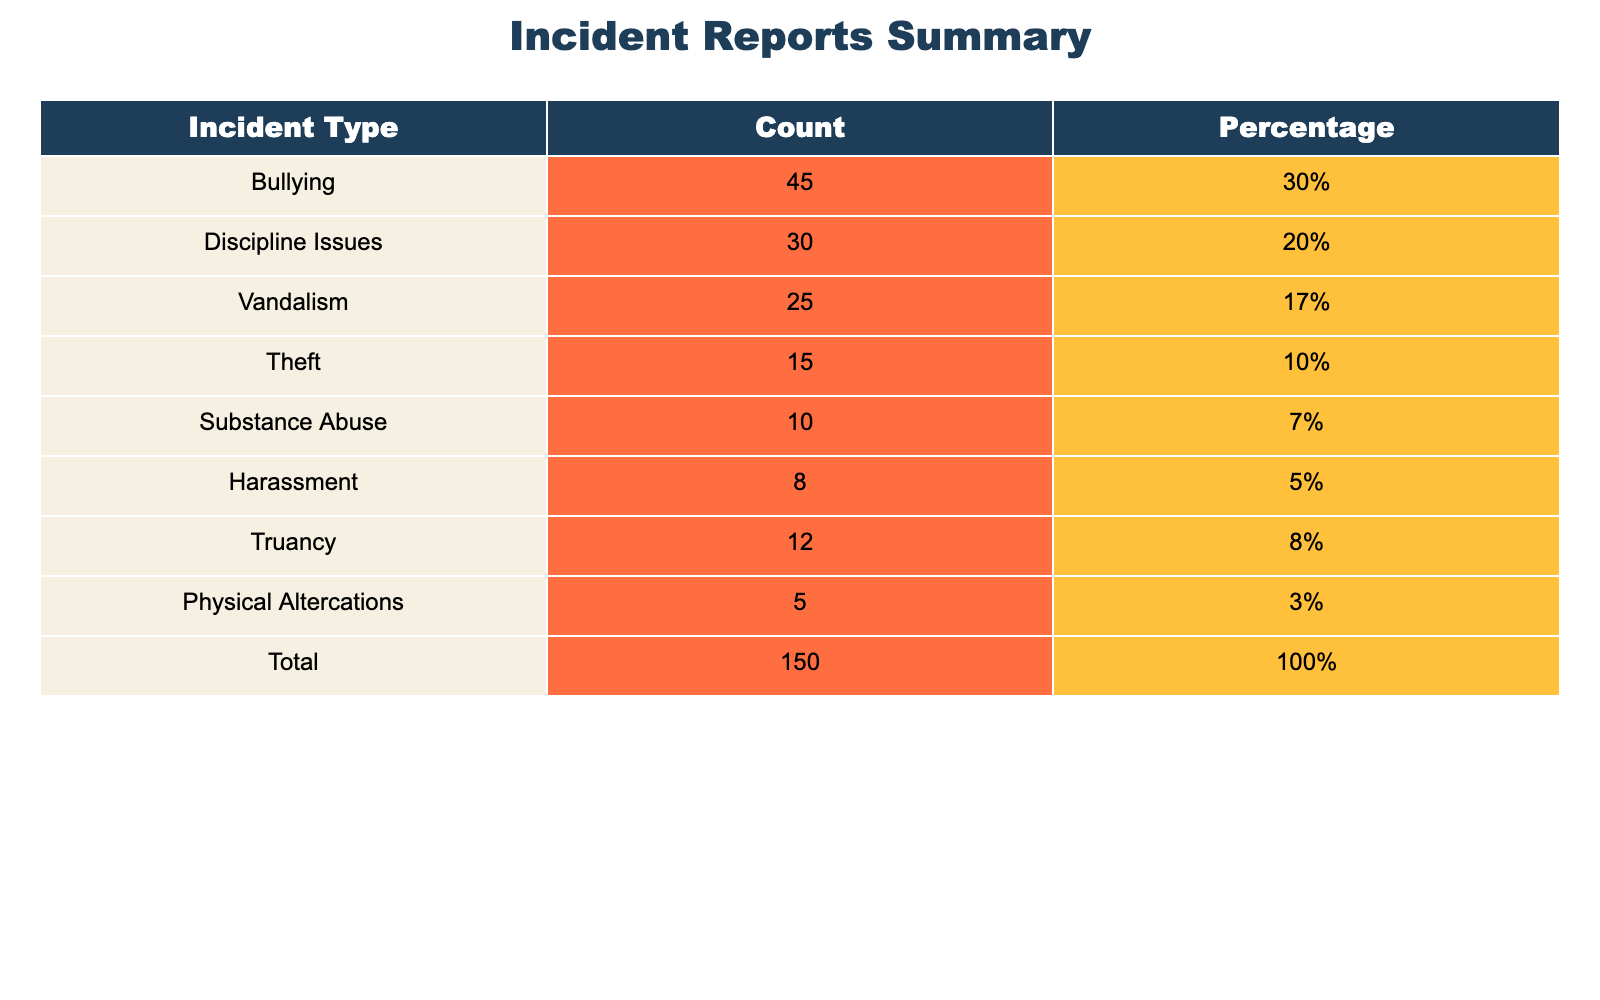What is the total number of incident reports? The total number of incident reports is given in the last row of the table under the "Total" column, which states 150.
Answer: 150 What percentage of incidents are related to bullying? The percentage related to bullying is found directly in the table under the "Percentage" column for "Bullying," which is 30%.
Answer: 30% How many incidents were reported for theft? The count of incidents for theft can be directly found in the "Count" column next to "Theft," which is 15.
Answer: 15 What is the combined number of incidents for substance abuse and harassment? To find the combined number, we add the counts for substance abuse (10) and harassment (8) together: 10 + 8 = 18.
Answer: 18 Is it true that bullying incidents account for more than a fifth of the total incidents? We check if bullying incidents, which are 45, represent more than 20% of the total incidents (150). Calculating 20% of 150 gives 30, and since 45 is greater than 30, the statement is true.
Answer: Yes How does the number of vandalism incidents compare to truancy incidents? Vandalism has 25 incidents, and truancy has 12. Since 25 is greater than 12, vandalism incidents are higher than truancy incidents.
Answer: Vandalism incidents are higher What percentage of the total incidents are characterized by discipline issues and physical altercations combined? First, we find the counts for discipline issues (30) and physical altercations (5) and add them: 30 + 5 = 35. To find the percentage, we use the formula (35 / 150) * 100 = 23.33%.
Answer: 23.33% What type of incident has the least occurrence, and what is its count? By looking at the "Count" column, we see that physical altercations have the lowest count at 5 incidents.
Answer: Physical altercations; 5 If we removed the incidents of harassment, what would the new total count be? The original total count is 150. Since harassment has 8 incidents, we subtract those from the total: 150 - 8 = 142.
Answer: 142 